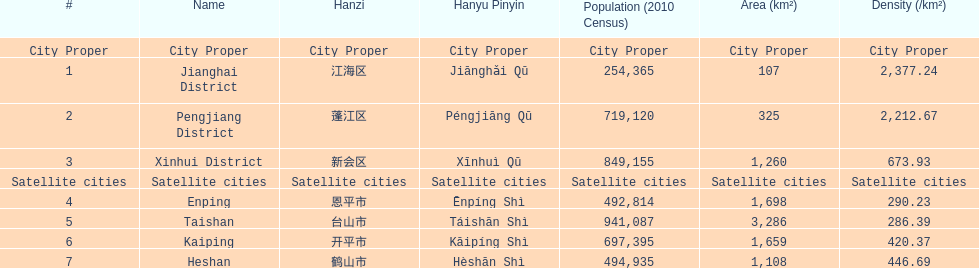Which area is the least dense? Taishan. 